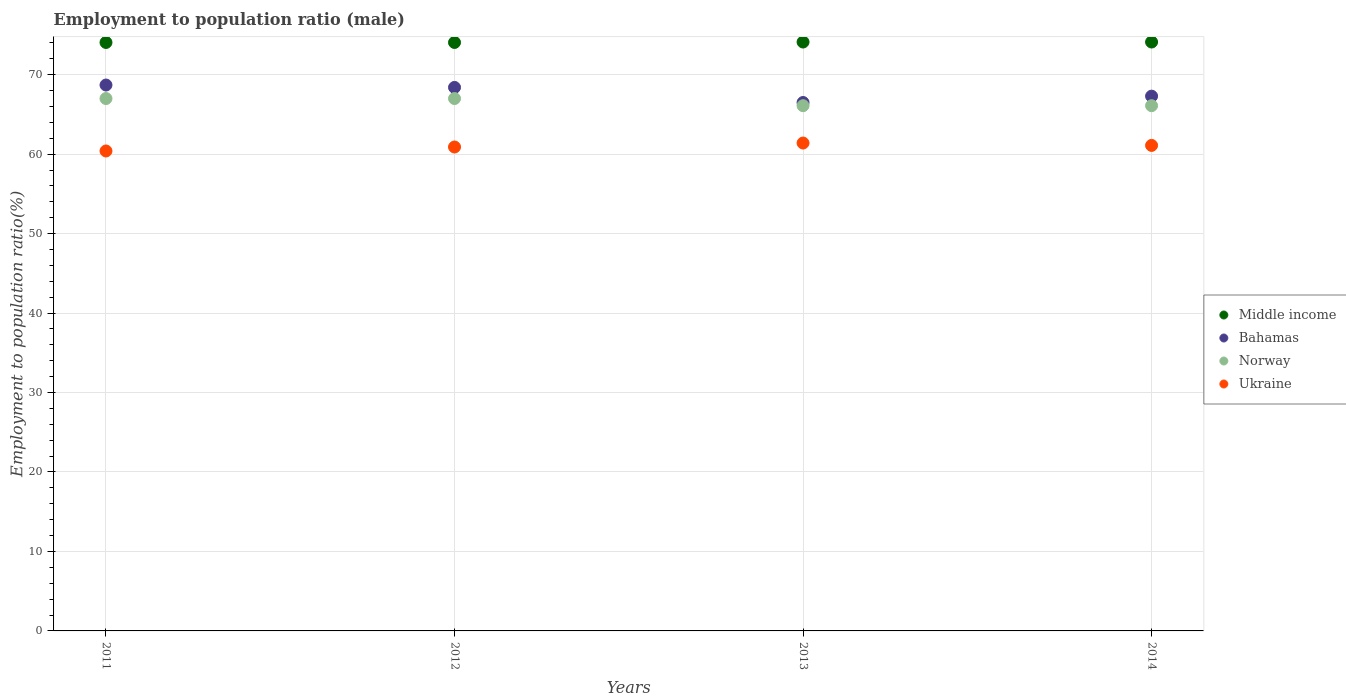How many different coloured dotlines are there?
Ensure brevity in your answer.  4. Is the number of dotlines equal to the number of legend labels?
Make the answer very short. Yes. What is the employment to population ratio in Bahamas in 2014?
Make the answer very short. 67.3. Across all years, what is the maximum employment to population ratio in Bahamas?
Provide a succinct answer. 68.7. Across all years, what is the minimum employment to population ratio in Bahamas?
Provide a succinct answer. 66.5. In which year was the employment to population ratio in Middle income maximum?
Your answer should be compact. 2014. In which year was the employment to population ratio in Middle income minimum?
Your response must be concise. 2012. What is the total employment to population ratio in Norway in the graph?
Give a very brief answer. 266.2. What is the difference between the employment to population ratio in Middle income in 2011 and that in 2012?
Offer a very short reply. 0. What is the difference between the employment to population ratio in Bahamas in 2011 and the employment to population ratio in Middle income in 2013?
Your answer should be compact. -5.41. What is the average employment to population ratio in Bahamas per year?
Keep it short and to the point. 67.73. In the year 2011, what is the difference between the employment to population ratio in Ukraine and employment to population ratio in Middle income?
Provide a short and direct response. -13.66. In how many years, is the employment to population ratio in Ukraine greater than 8 %?
Make the answer very short. 4. What is the ratio of the employment to population ratio in Bahamas in 2013 to that in 2014?
Offer a very short reply. 0.99. What is the difference between the highest and the second highest employment to population ratio in Norway?
Offer a very short reply. 0. What is the difference between the highest and the lowest employment to population ratio in Middle income?
Give a very brief answer. 0.06. In how many years, is the employment to population ratio in Bahamas greater than the average employment to population ratio in Bahamas taken over all years?
Provide a short and direct response. 2. Is the sum of the employment to population ratio in Ukraine in 2011 and 2012 greater than the maximum employment to population ratio in Middle income across all years?
Provide a short and direct response. Yes. Is it the case that in every year, the sum of the employment to population ratio in Ukraine and employment to population ratio in Norway  is greater than the sum of employment to population ratio in Middle income and employment to population ratio in Bahamas?
Keep it short and to the point. No. Is it the case that in every year, the sum of the employment to population ratio in Bahamas and employment to population ratio in Ukraine  is greater than the employment to population ratio in Norway?
Offer a terse response. Yes. Does the employment to population ratio in Norway monotonically increase over the years?
Give a very brief answer. No. Is the employment to population ratio in Bahamas strictly greater than the employment to population ratio in Norway over the years?
Make the answer very short. Yes. Is the employment to population ratio in Bahamas strictly less than the employment to population ratio in Middle income over the years?
Ensure brevity in your answer.  Yes. Are the values on the major ticks of Y-axis written in scientific E-notation?
Keep it short and to the point. No. Does the graph contain grids?
Keep it short and to the point. Yes. Where does the legend appear in the graph?
Provide a succinct answer. Center right. How are the legend labels stacked?
Your answer should be compact. Vertical. What is the title of the graph?
Your response must be concise. Employment to population ratio (male). What is the label or title of the Y-axis?
Make the answer very short. Employment to population ratio(%). What is the Employment to population ratio(%) of Middle income in 2011?
Give a very brief answer. 74.06. What is the Employment to population ratio(%) in Bahamas in 2011?
Provide a short and direct response. 68.7. What is the Employment to population ratio(%) in Ukraine in 2011?
Your answer should be very brief. 60.4. What is the Employment to population ratio(%) in Middle income in 2012?
Your answer should be very brief. 74.06. What is the Employment to population ratio(%) of Bahamas in 2012?
Keep it short and to the point. 68.4. What is the Employment to population ratio(%) in Norway in 2012?
Make the answer very short. 67. What is the Employment to population ratio(%) of Ukraine in 2012?
Offer a very short reply. 60.9. What is the Employment to population ratio(%) of Middle income in 2013?
Offer a terse response. 74.11. What is the Employment to population ratio(%) in Bahamas in 2013?
Provide a short and direct response. 66.5. What is the Employment to population ratio(%) of Norway in 2013?
Provide a succinct answer. 66.1. What is the Employment to population ratio(%) in Ukraine in 2013?
Offer a very short reply. 61.4. What is the Employment to population ratio(%) in Middle income in 2014?
Your response must be concise. 74.11. What is the Employment to population ratio(%) in Bahamas in 2014?
Provide a short and direct response. 67.3. What is the Employment to population ratio(%) of Norway in 2014?
Ensure brevity in your answer.  66.1. What is the Employment to population ratio(%) in Ukraine in 2014?
Offer a very short reply. 61.1. Across all years, what is the maximum Employment to population ratio(%) in Middle income?
Offer a very short reply. 74.11. Across all years, what is the maximum Employment to population ratio(%) in Bahamas?
Offer a very short reply. 68.7. Across all years, what is the maximum Employment to population ratio(%) in Norway?
Give a very brief answer. 67. Across all years, what is the maximum Employment to population ratio(%) in Ukraine?
Offer a terse response. 61.4. Across all years, what is the minimum Employment to population ratio(%) of Middle income?
Your answer should be very brief. 74.06. Across all years, what is the minimum Employment to population ratio(%) in Bahamas?
Offer a very short reply. 66.5. Across all years, what is the minimum Employment to population ratio(%) in Norway?
Your answer should be very brief. 66.1. Across all years, what is the minimum Employment to population ratio(%) in Ukraine?
Keep it short and to the point. 60.4. What is the total Employment to population ratio(%) of Middle income in the graph?
Provide a short and direct response. 296.33. What is the total Employment to population ratio(%) of Bahamas in the graph?
Your answer should be very brief. 270.9. What is the total Employment to population ratio(%) of Norway in the graph?
Keep it short and to the point. 266.2. What is the total Employment to population ratio(%) of Ukraine in the graph?
Provide a short and direct response. 243.8. What is the difference between the Employment to population ratio(%) of Middle income in 2011 and that in 2012?
Your answer should be compact. 0. What is the difference between the Employment to population ratio(%) of Middle income in 2011 and that in 2013?
Keep it short and to the point. -0.05. What is the difference between the Employment to population ratio(%) of Bahamas in 2011 and that in 2013?
Provide a succinct answer. 2.2. What is the difference between the Employment to population ratio(%) of Middle income in 2011 and that in 2014?
Your response must be concise. -0.06. What is the difference between the Employment to population ratio(%) in Norway in 2011 and that in 2014?
Provide a succinct answer. 0.9. What is the difference between the Employment to population ratio(%) in Middle income in 2012 and that in 2013?
Your response must be concise. -0.06. What is the difference between the Employment to population ratio(%) of Bahamas in 2012 and that in 2013?
Provide a succinct answer. 1.9. What is the difference between the Employment to population ratio(%) of Middle income in 2012 and that in 2014?
Offer a very short reply. -0.06. What is the difference between the Employment to population ratio(%) in Bahamas in 2012 and that in 2014?
Provide a succinct answer. 1.1. What is the difference between the Employment to population ratio(%) of Norway in 2012 and that in 2014?
Offer a very short reply. 0.9. What is the difference between the Employment to population ratio(%) in Middle income in 2013 and that in 2014?
Your answer should be very brief. -0. What is the difference between the Employment to population ratio(%) of Bahamas in 2013 and that in 2014?
Your response must be concise. -0.8. What is the difference between the Employment to population ratio(%) in Middle income in 2011 and the Employment to population ratio(%) in Bahamas in 2012?
Your answer should be compact. 5.66. What is the difference between the Employment to population ratio(%) in Middle income in 2011 and the Employment to population ratio(%) in Norway in 2012?
Your response must be concise. 7.06. What is the difference between the Employment to population ratio(%) of Middle income in 2011 and the Employment to population ratio(%) of Ukraine in 2012?
Offer a terse response. 13.16. What is the difference between the Employment to population ratio(%) in Bahamas in 2011 and the Employment to population ratio(%) in Norway in 2012?
Make the answer very short. 1.7. What is the difference between the Employment to population ratio(%) in Middle income in 2011 and the Employment to population ratio(%) in Bahamas in 2013?
Provide a succinct answer. 7.56. What is the difference between the Employment to population ratio(%) of Middle income in 2011 and the Employment to population ratio(%) of Norway in 2013?
Ensure brevity in your answer.  7.96. What is the difference between the Employment to population ratio(%) in Middle income in 2011 and the Employment to population ratio(%) in Ukraine in 2013?
Offer a very short reply. 12.66. What is the difference between the Employment to population ratio(%) of Bahamas in 2011 and the Employment to population ratio(%) of Ukraine in 2013?
Provide a succinct answer. 7.3. What is the difference between the Employment to population ratio(%) in Norway in 2011 and the Employment to population ratio(%) in Ukraine in 2013?
Ensure brevity in your answer.  5.6. What is the difference between the Employment to population ratio(%) in Middle income in 2011 and the Employment to population ratio(%) in Bahamas in 2014?
Keep it short and to the point. 6.76. What is the difference between the Employment to population ratio(%) of Middle income in 2011 and the Employment to population ratio(%) of Norway in 2014?
Offer a terse response. 7.96. What is the difference between the Employment to population ratio(%) in Middle income in 2011 and the Employment to population ratio(%) in Ukraine in 2014?
Ensure brevity in your answer.  12.96. What is the difference between the Employment to population ratio(%) of Middle income in 2012 and the Employment to population ratio(%) of Bahamas in 2013?
Provide a short and direct response. 7.56. What is the difference between the Employment to population ratio(%) in Middle income in 2012 and the Employment to population ratio(%) in Norway in 2013?
Your answer should be very brief. 7.96. What is the difference between the Employment to population ratio(%) in Middle income in 2012 and the Employment to population ratio(%) in Ukraine in 2013?
Provide a succinct answer. 12.66. What is the difference between the Employment to population ratio(%) of Bahamas in 2012 and the Employment to population ratio(%) of Ukraine in 2013?
Offer a terse response. 7. What is the difference between the Employment to population ratio(%) in Norway in 2012 and the Employment to population ratio(%) in Ukraine in 2013?
Give a very brief answer. 5.6. What is the difference between the Employment to population ratio(%) in Middle income in 2012 and the Employment to population ratio(%) in Bahamas in 2014?
Ensure brevity in your answer.  6.76. What is the difference between the Employment to population ratio(%) of Middle income in 2012 and the Employment to population ratio(%) of Norway in 2014?
Keep it short and to the point. 7.96. What is the difference between the Employment to population ratio(%) of Middle income in 2012 and the Employment to population ratio(%) of Ukraine in 2014?
Your response must be concise. 12.96. What is the difference between the Employment to population ratio(%) in Middle income in 2013 and the Employment to population ratio(%) in Bahamas in 2014?
Make the answer very short. 6.81. What is the difference between the Employment to population ratio(%) in Middle income in 2013 and the Employment to population ratio(%) in Norway in 2014?
Offer a terse response. 8.01. What is the difference between the Employment to population ratio(%) in Middle income in 2013 and the Employment to population ratio(%) in Ukraine in 2014?
Provide a short and direct response. 13.01. What is the difference between the Employment to population ratio(%) of Bahamas in 2013 and the Employment to population ratio(%) of Norway in 2014?
Your answer should be very brief. 0.4. What is the difference between the Employment to population ratio(%) in Bahamas in 2013 and the Employment to population ratio(%) in Ukraine in 2014?
Provide a short and direct response. 5.4. What is the average Employment to population ratio(%) in Middle income per year?
Your answer should be very brief. 74.08. What is the average Employment to population ratio(%) in Bahamas per year?
Keep it short and to the point. 67.72. What is the average Employment to population ratio(%) in Norway per year?
Keep it short and to the point. 66.55. What is the average Employment to population ratio(%) in Ukraine per year?
Your answer should be compact. 60.95. In the year 2011, what is the difference between the Employment to population ratio(%) in Middle income and Employment to population ratio(%) in Bahamas?
Your response must be concise. 5.36. In the year 2011, what is the difference between the Employment to population ratio(%) in Middle income and Employment to population ratio(%) in Norway?
Provide a short and direct response. 7.06. In the year 2011, what is the difference between the Employment to population ratio(%) of Middle income and Employment to population ratio(%) of Ukraine?
Your response must be concise. 13.66. In the year 2011, what is the difference between the Employment to population ratio(%) in Norway and Employment to population ratio(%) in Ukraine?
Offer a very short reply. 6.6. In the year 2012, what is the difference between the Employment to population ratio(%) of Middle income and Employment to population ratio(%) of Bahamas?
Provide a succinct answer. 5.66. In the year 2012, what is the difference between the Employment to population ratio(%) of Middle income and Employment to population ratio(%) of Norway?
Make the answer very short. 7.06. In the year 2012, what is the difference between the Employment to population ratio(%) of Middle income and Employment to population ratio(%) of Ukraine?
Give a very brief answer. 13.16. In the year 2012, what is the difference between the Employment to population ratio(%) in Bahamas and Employment to population ratio(%) in Ukraine?
Provide a short and direct response. 7.5. In the year 2013, what is the difference between the Employment to population ratio(%) of Middle income and Employment to population ratio(%) of Bahamas?
Ensure brevity in your answer.  7.61. In the year 2013, what is the difference between the Employment to population ratio(%) of Middle income and Employment to population ratio(%) of Norway?
Ensure brevity in your answer.  8.01. In the year 2013, what is the difference between the Employment to population ratio(%) in Middle income and Employment to population ratio(%) in Ukraine?
Provide a short and direct response. 12.71. In the year 2013, what is the difference between the Employment to population ratio(%) in Bahamas and Employment to population ratio(%) in Ukraine?
Give a very brief answer. 5.1. In the year 2014, what is the difference between the Employment to population ratio(%) of Middle income and Employment to population ratio(%) of Bahamas?
Your response must be concise. 6.81. In the year 2014, what is the difference between the Employment to population ratio(%) in Middle income and Employment to population ratio(%) in Norway?
Offer a terse response. 8.01. In the year 2014, what is the difference between the Employment to population ratio(%) in Middle income and Employment to population ratio(%) in Ukraine?
Your answer should be very brief. 13.01. In the year 2014, what is the difference between the Employment to population ratio(%) in Bahamas and Employment to population ratio(%) in Norway?
Your answer should be compact. 1.2. In the year 2014, what is the difference between the Employment to population ratio(%) in Bahamas and Employment to population ratio(%) in Ukraine?
Make the answer very short. 6.2. What is the ratio of the Employment to population ratio(%) in Bahamas in 2011 to that in 2012?
Your response must be concise. 1. What is the ratio of the Employment to population ratio(%) in Ukraine in 2011 to that in 2012?
Provide a short and direct response. 0.99. What is the ratio of the Employment to population ratio(%) in Bahamas in 2011 to that in 2013?
Provide a succinct answer. 1.03. What is the ratio of the Employment to population ratio(%) of Norway in 2011 to that in 2013?
Your answer should be very brief. 1.01. What is the ratio of the Employment to population ratio(%) of Ukraine in 2011 to that in 2013?
Ensure brevity in your answer.  0.98. What is the ratio of the Employment to population ratio(%) of Middle income in 2011 to that in 2014?
Ensure brevity in your answer.  1. What is the ratio of the Employment to population ratio(%) in Bahamas in 2011 to that in 2014?
Offer a very short reply. 1.02. What is the ratio of the Employment to population ratio(%) in Norway in 2011 to that in 2014?
Provide a succinct answer. 1.01. What is the ratio of the Employment to population ratio(%) in Ukraine in 2011 to that in 2014?
Ensure brevity in your answer.  0.99. What is the ratio of the Employment to population ratio(%) in Middle income in 2012 to that in 2013?
Give a very brief answer. 1. What is the ratio of the Employment to population ratio(%) of Bahamas in 2012 to that in 2013?
Your answer should be compact. 1.03. What is the ratio of the Employment to population ratio(%) of Norway in 2012 to that in 2013?
Your answer should be very brief. 1.01. What is the ratio of the Employment to population ratio(%) in Ukraine in 2012 to that in 2013?
Make the answer very short. 0.99. What is the ratio of the Employment to population ratio(%) of Bahamas in 2012 to that in 2014?
Provide a short and direct response. 1.02. What is the ratio of the Employment to population ratio(%) of Norway in 2012 to that in 2014?
Provide a short and direct response. 1.01. What is the ratio of the Employment to population ratio(%) of Middle income in 2013 to that in 2014?
Your response must be concise. 1. What is the ratio of the Employment to population ratio(%) of Ukraine in 2013 to that in 2014?
Provide a succinct answer. 1. What is the difference between the highest and the second highest Employment to population ratio(%) of Middle income?
Keep it short and to the point. 0. What is the difference between the highest and the second highest Employment to population ratio(%) of Bahamas?
Your answer should be compact. 0.3. What is the difference between the highest and the second highest Employment to population ratio(%) in Ukraine?
Your answer should be compact. 0.3. What is the difference between the highest and the lowest Employment to population ratio(%) of Middle income?
Give a very brief answer. 0.06. What is the difference between the highest and the lowest Employment to population ratio(%) in Bahamas?
Ensure brevity in your answer.  2.2. What is the difference between the highest and the lowest Employment to population ratio(%) of Ukraine?
Provide a succinct answer. 1. 